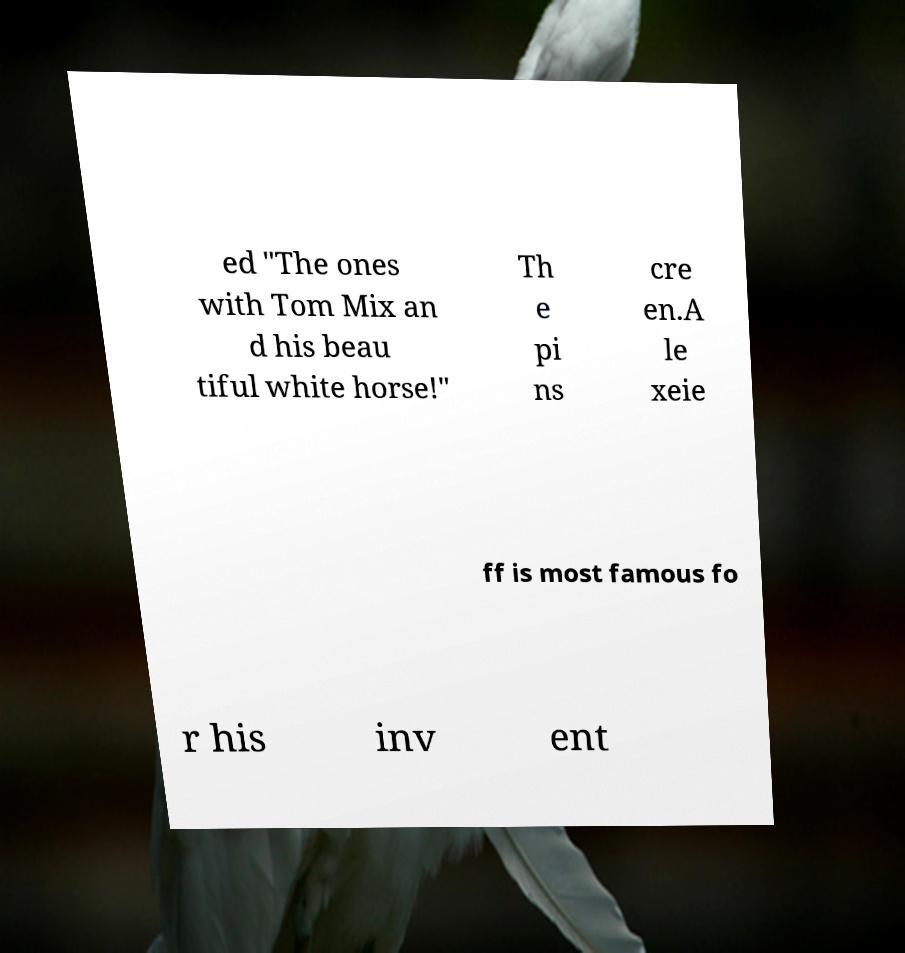Could you assist in decoding the text presented in this image and type it out clearly? ed "The ones with Tom Mix an d his beau tiful white horse!" Th e pi ns cre en.A le xeie ff is most famous fo r his inv ent 